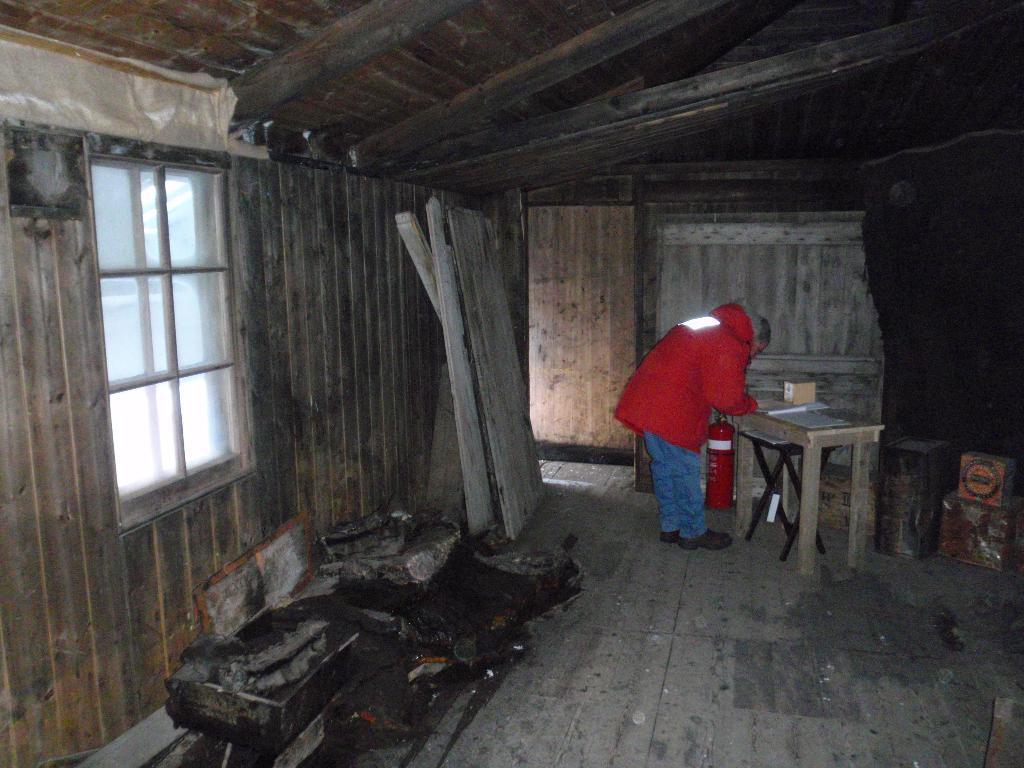How would you summarize this image in a sentence or two? As we can see in the image there is a house, window, a man standing over here and a table. On table there is a box. 